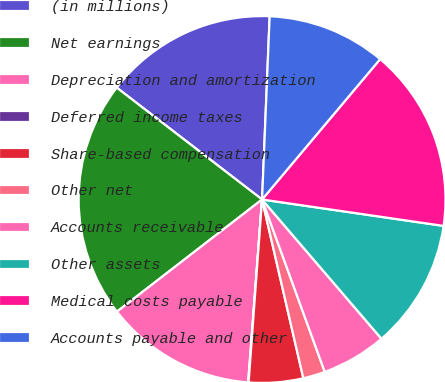Convert chart. <chart><loc_0><loc_0><loc_500><loc_500><pie_chart><fcel>(in millions)<fcel>Net earnings<fcel>Depreciation and amortization<fcel>Deferred income taxes<fcel>Share-based compensation<fcel>Other net<fcel>Accounts receivable<fcel>Other assets<fcel>Medical costs payable<fcel>Accounts payable and other<nl><fcel>15.22%<fcel>20.91%<fcel>13.32%<fcel>0.04%<fcel>4.78%<fcel>1.94%<fcel>5.73%<fcel>11.42%<fcel>16.17%<fcel>10.47%<nl></chart> 